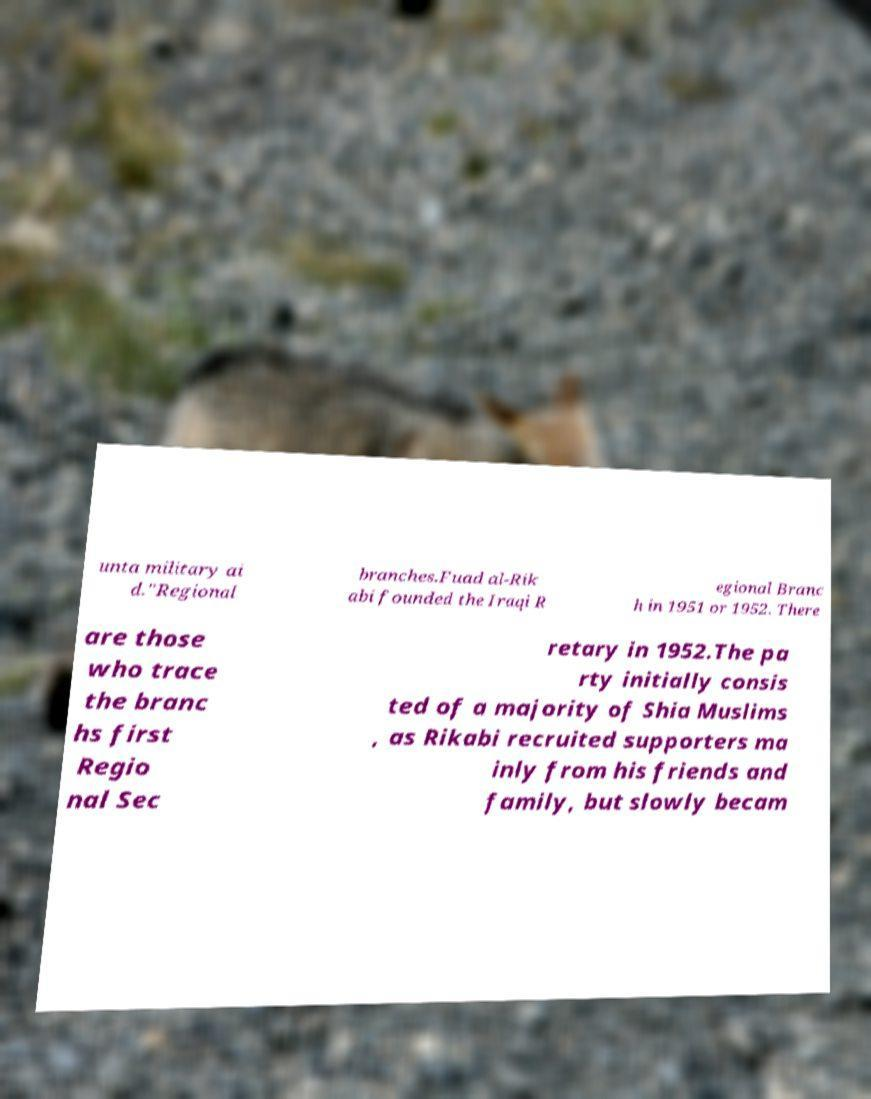Please read and relay the text visible in this image. What does it say? unta military ai d."Regional branches.Fuad al-Rik abi founded the Iraqi R egional Branc h in 1951 or 1952. There are those who trace the branc hs first Regio nal Sec retary in 1952.The pa rty initially consis ted of a majority of Shia Muslims , as Rikabi recruited supporters ma inly from his friends and family, but slowly becam 